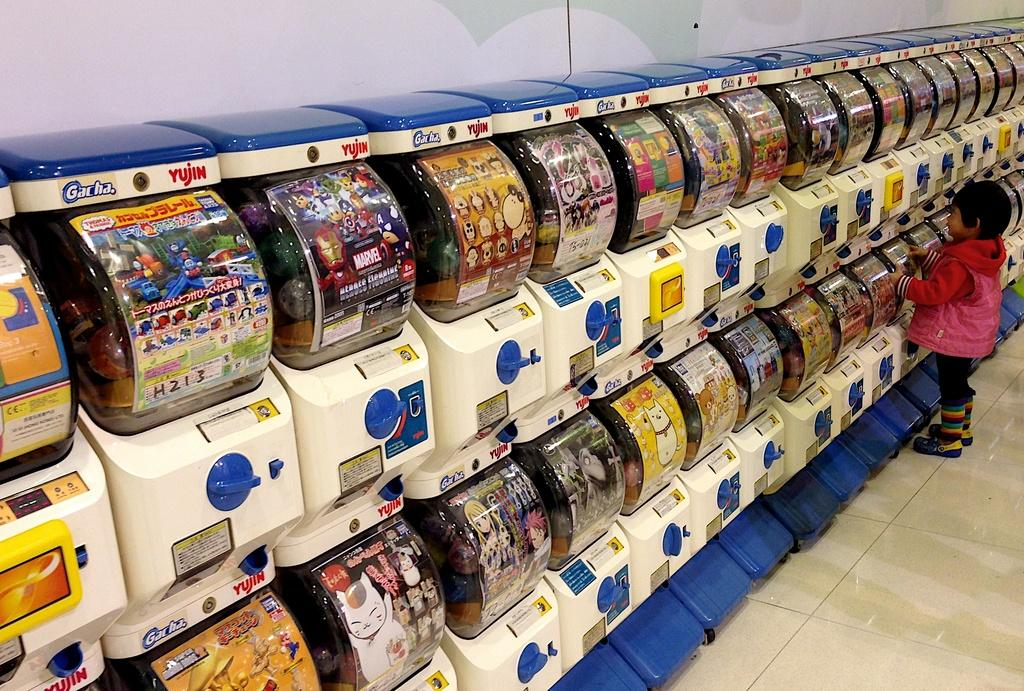Provide a one-sentence caption for the provided image. A young girl looks at candy in Gacha Yujin display containers. 